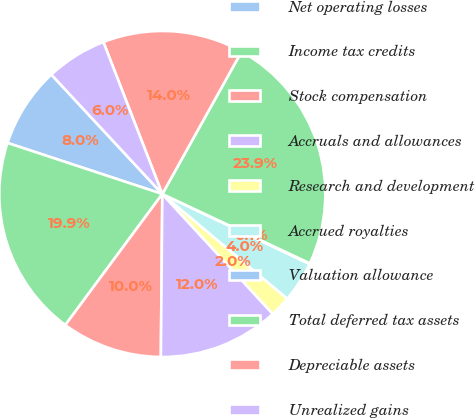<chart> <loc_0><loc_0><loc_500><loc_500><pie_chart><fcel>Net operating losses<fcel>Income tax credits<fcel>Stock compensation<fcel>Accruals and allowances<fcel>Research and development<fcel>Accrued royalties<fcel>Valuation allowance<fcel>Total deferred tax assets<fcel>Depreciable assets<fcel>Unrealized gains<nl><fcel>8.01%<fcel>19.93%<fcel>10.0%<fcel>11.99%<fcel>2.05%<fcel>4.04%<fcel>0.07%<fcel>23.91%<fcel>13.97%<fcel>6.03%<nl></chart> 